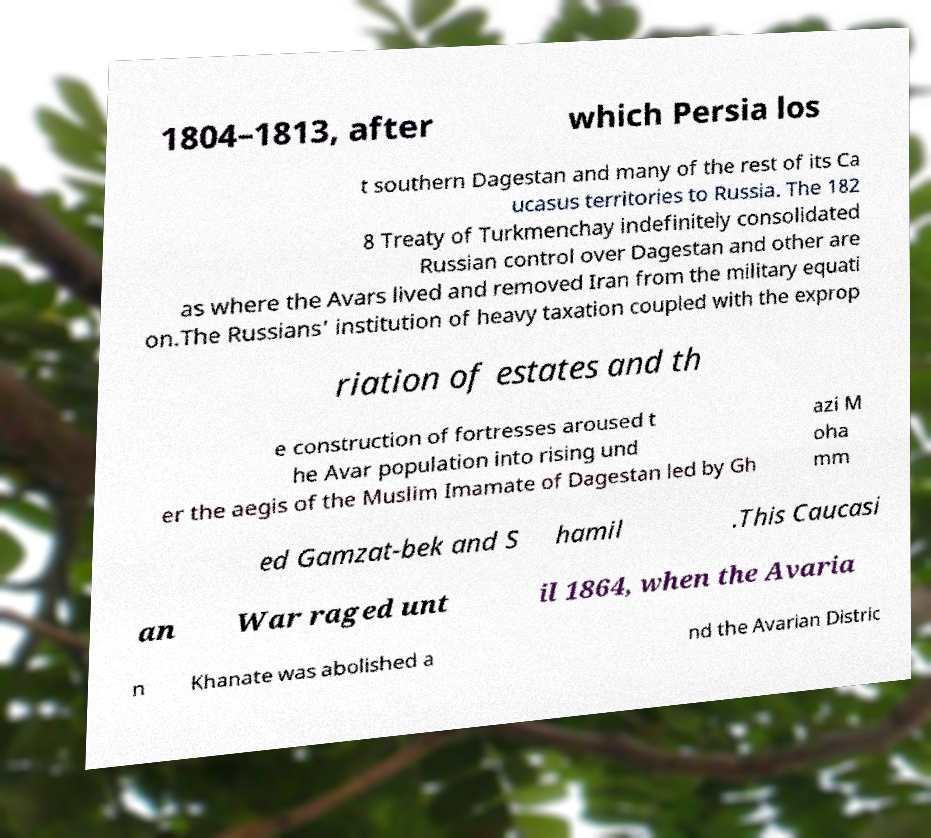I need the written content from this picture converted into text. Can you do that? 1804–1813, after which Persia los t southern Dagestan and many of the rest of its Ca ucasus territories to Russia. The 182 8 Treaty of Turkmenchay indefinitely consolidated Russian control over Dagestan and other are as where the Avars lived and removed Iran from the military equati on.The Russians' institution of heavy taxation coupled with the exprop riation of estates and th e construction of fortresses aroused t he Avar population into rising und er the aegis of the Muslim Imamate of Dagestan led by Gh azi M oha mm ed Gamzat-bek and S hamil .This Caucasi an War raged unt il 1864, when the Avaria n Khanate was abolished a nd the Avarian Distric 